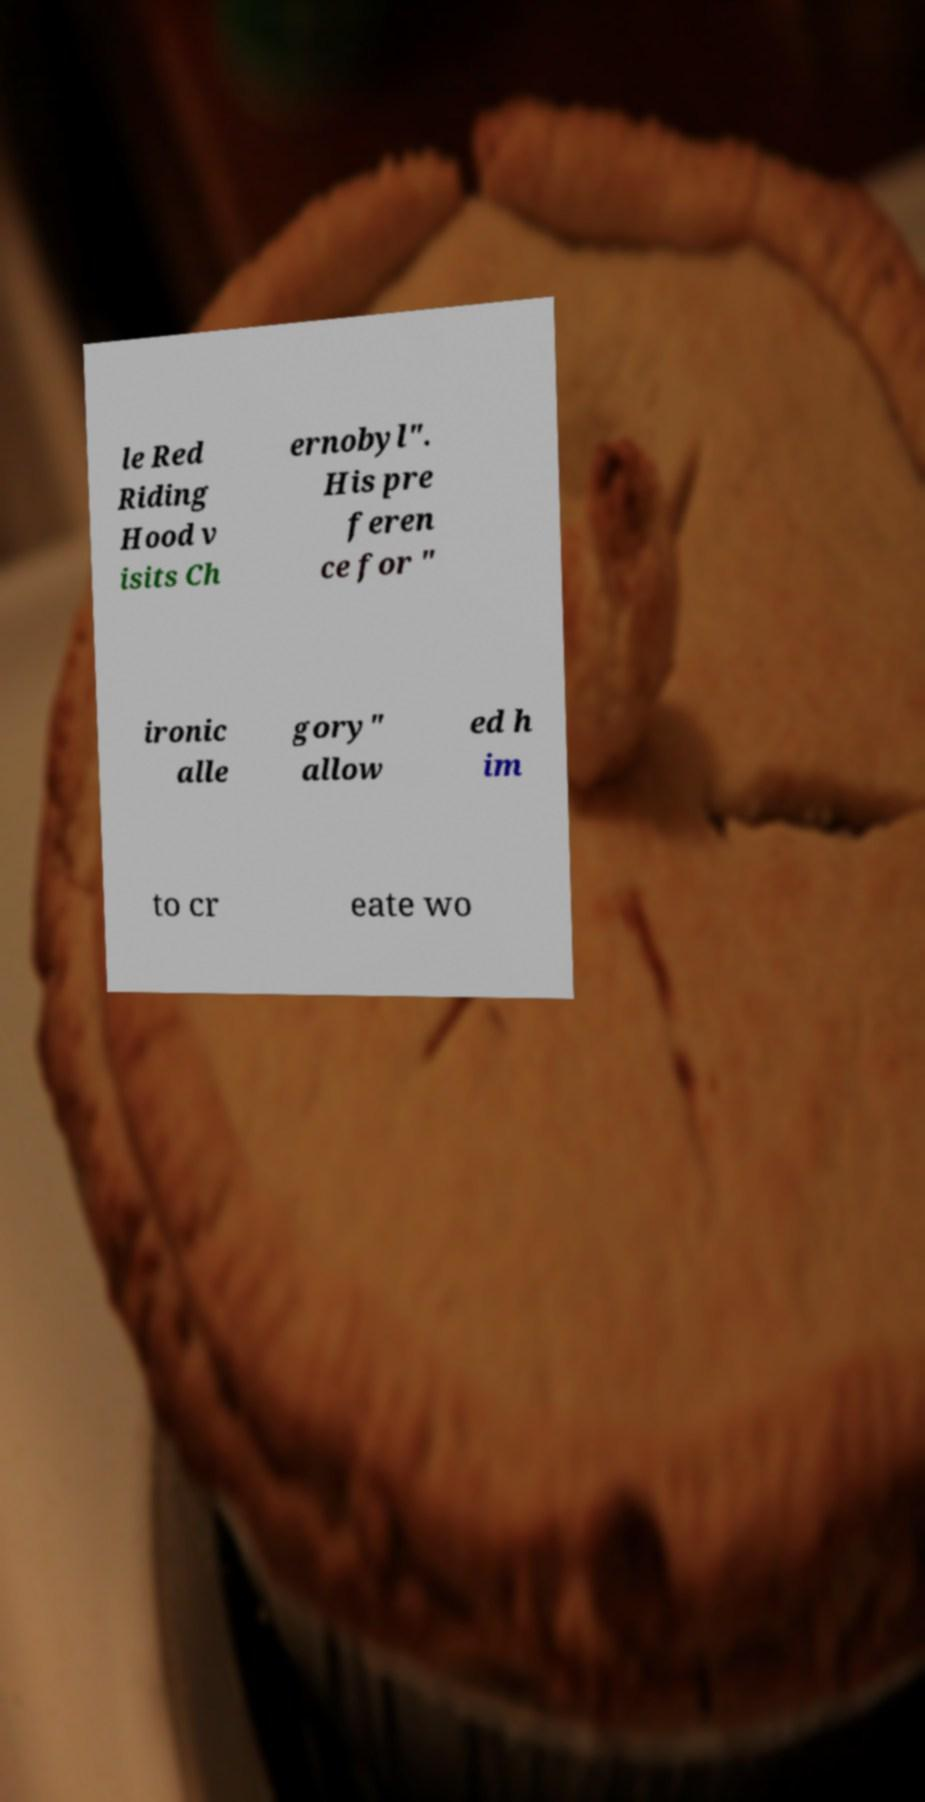Could you assist in decoding the text presented in this image and type it out clearly? le Red Riding Hood v isits Ch ernobyl". His pre feren ce for " ironic alle gory" allow ed h im to cr eate wo 